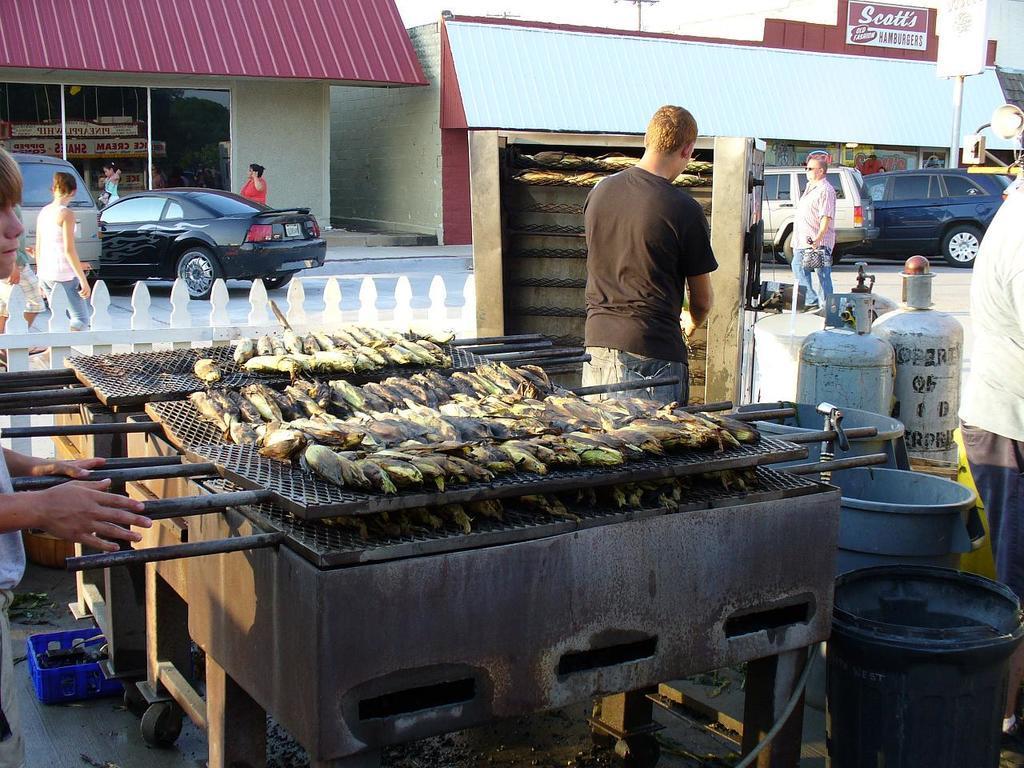In one or two sentences, can you explain what this image depicts? In this image I see the road on which there are few cars and I see few people and I see food on these things and I see the container over here and I see few buckets over here. In the background I see the buildings and I see something written over here and I see a pole over here. 